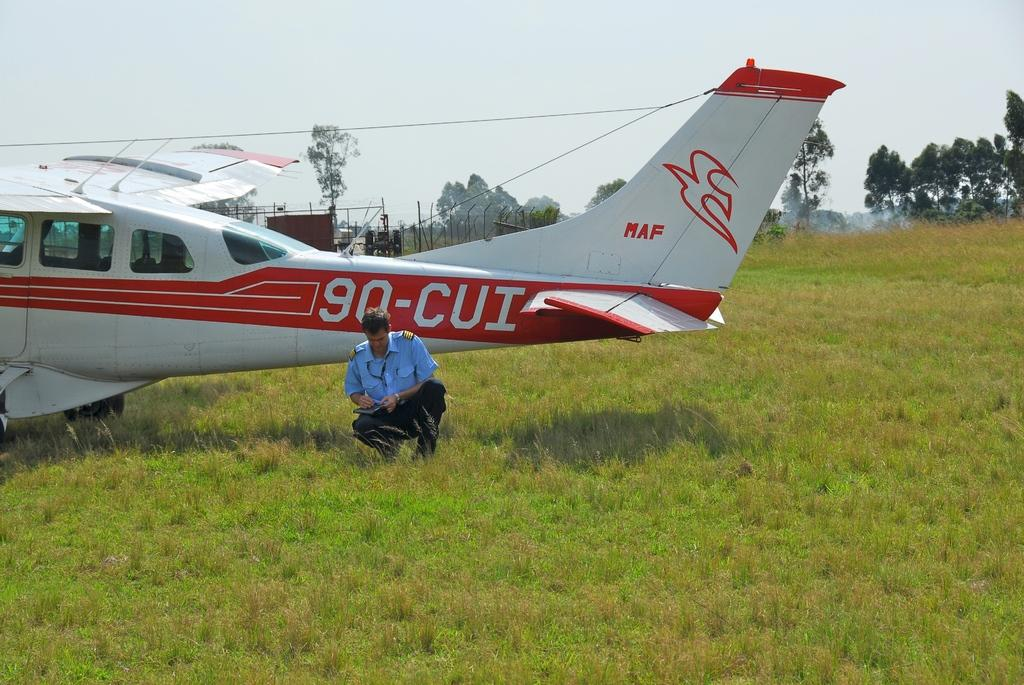<image>
Give a short and clear explanation of the subsequent image. Tail of an Airplane that says 90-CUI with a man kneeling below it. 